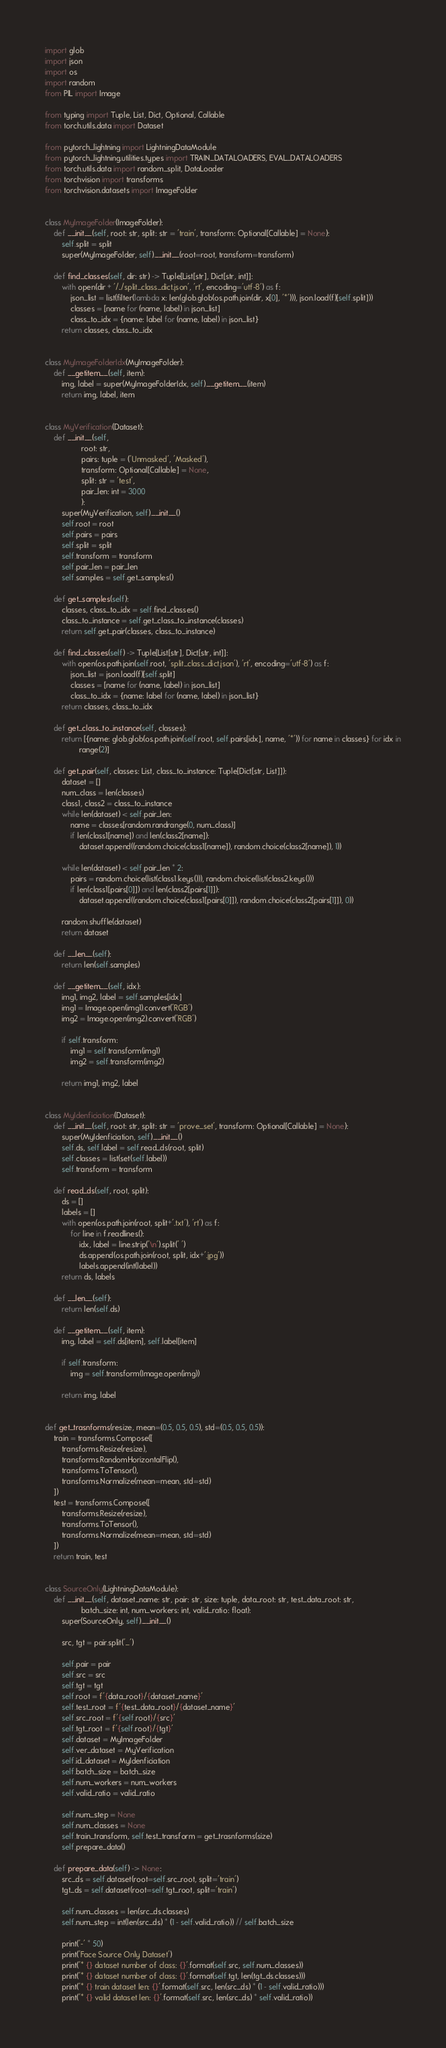Convert code to text. <code><loc_0><loc_0><loc_500><loc_500><_Python_>import glob
import json
import os
import random
from PIL import Image

from typing import Tuple, List, Dict, Optional, Callable
from torch.utils.data import Dataset

from pytorch_lightning import LightningDataModule
from pytorch_lightning.utilities.types import TRAIN_DATALOADERS, EVAL_DATALOADERS
from torch.utils.data import random_split, DataLoader
from torchvision import transforms
from torchvision.datasets import ImageFolder


class MyImageFolder(ImageFolder):
    def __init__(self, root: str, split: str = 'train', transform: Optional[Callable] = None):
        self.split = split
        super(MyImageFolder, self).__init__(root=root, transform=transform)

    def find_classes(self, dir: str) -> Tuple[List[str], Dict[str, int]]:
        with open(dir + '/../split_class_dict.json', 'rt', encoding='utf-8') as f:
            json_list = list(filter(lambda x: len(glob.glob(os.path.join(dir, x[0], '*'))), json.load(f)[self.split]))
            classes = [name for (name, label) in json_list]
            class_to_idx = {name: label for (name, label) in json_list}
        return classes, class_to_idx


class MyImageFolderIdx(MyImageFolder):
    def __getitem__(self, item):
        img, label = super(MyImageFolderIdx, self).__getitem__(item)
        return img, label, item


class MyVerification(Dataset):
    def __init__(self,
                 root: str,
                 pairs: tuple = ('Unmasked', 'Masked'),
                 transform: Optional[Callable] = None,
                 split: str = 'test',
                 pair_len: int = 3000
                 ):
        super(MyVerification, self).__init__()
        self.root = root
        self.pairs = pairs
        self.split = split
        self.transform = transform
        self.pair_len = pair_len
        self.samples = self.get_samples()

    def get_samples(self):
        classes, class_to_idx = self.find_classes()
        class_to_instance = self.get_class_to_instance(classes)
        return self.get_pair(classes, class_to_instance)

    def find_classes(self) -> Tuple[List[str], Dict[str, int]]:
        with open(os.path.join(self.root, 'split_class_dict.json'), 'rt', encoding='utf-8') as f:
            json_list = json.load(f)[self.split]
            classes = [name for (name, label) in json_list]
            class_to_idx = {name: label for (name, label) in json_list}
        return classes, class_to_idx

    def get_class_to_instance(self, classes):
        return [{name: glob.glob(os.path.join(self.root, self.pairs[idx], name, '*')) for name in classes} for idx in
                range(2)]

    def get_pair(self, classes: List, class_to_instance: Tuple[Dict[str, List]]):
        dataset = []
        num_class = len(classes)
        class1, class2 = class_to_instance
        while len(dataset) < self.pair_len:
            name = classes[random.randrange(0, num_class)]
            if len(class1[name]) and len(class2[name]):
                dataset.append((random.choice(class1[name]), random.choice(class2[name]), 1))

        while len(dataset) < self.pair_len * 2:
            pairs = random.choice(list(class1.keys())), random.choice(list(class2.keys()))
            if len(class1[pairs[0]]) and len(class2[pairs[1]]):
                dataset.append((random.choice(class1[pairs[0]]), random.choice(class2[pairs[1]]), 0))

        random.shuffle(dataset)
        return dataset

    def __len__(self):
        return len(self.samples)

    def __getitem__(self, idx):
        img1, img2, label = self.samples[idx]
        img1 = Image.open(img1).convert('RGB')
        img2 = Image.open(img2).convert('RGB')

        if self.transform:
            img1 = self.transform(img1)
            img2 = self.transform(img2)

        return img1, img2, label


class MyIdenficiation(Dataset):
    def __init__(self, root: str, split: str = 'prove_set', transform: Optional[Callable] = None):
        super(MyIdenficiation, self).__init__()
        self.ds, self.label = self.read_ds(root, split)
        self.classes = list(set(self.label))
        self.transform = transform

    def read_ds(self, root, split):
        ds = []
        labels = []
        with open(os.path.join(root, split+'.txt'), 'rt') as f:
            for line in f.readlines():
                idx, label = line.strip('\n').split(' ')
                ds.append(os.path.join(root, split, idx+'.jpg'))
                labels.append(int(label))
        return ds, labels

    def __len__(self):
        return len(self.ds)

    def __getitem__(self, item):
        img, label = self.ds[item], self.label[item]

        if self.transform:
            img = self.transform(Image.open(img))

        return img, label


def get_trasnforms(resize, mean=(0.5, 0.5, 0.5), std=(0.5, 0.5, 0.5)):
    train = transforms.Compose([
        transforms.Resize(resize),
        transforms.RandomHorizontalFlip(),
        transforms.ToTensor(),
        transforms.Normalize(mean=mean, std=std)
    ])
    test = transforms.Compose([
        transforms.Resize(resize),
        transforms.ToTensor(),
        transforms.Normalize(mean=mean, std=std)
    ])
    return train, test


class SourceOnly(LightningDataModule):
    def __init__(self, dataset_name: str, pair: str, size: tuple, data_root: str, test_data_root: str,
                 batch_size: int, num_workers: int, valid_ratio: float):
        super(SourceOnly, self).__init__()

        src, tgt = pair.split('_')

        self.pair = pair
        self.src = src
        self.tgt = tgt
        self.root = f'{data_root}/{dataset_name}'
        self.test_root = f'{test_data_root}/{dataset_name}'
        self.src_root = f'{self.root}/{src}'
        self.tgt_root = f'{self.root}/{tgt}'
        self.dataset = MyImageFolder
        self.ver_dataset = MyVerification
        self.id_dataset = MyIdenficiation
        self.batch_size = batch_size
        self.num_workers = num_workers
        self.valid_ratio = valid_ratio

        self.num_step = None
        self.num_classes = None
        self.train_transform, self.test_transform = get_trasnforms(size)
        self.prepare_data()

    def prepare_data(self) -> None:
        src_ds = self.dataset(root=self.src_root, split='train')
        tgt_ds = self.dataset(root=self.tgt_root, split='train')

        self.num_classes = len(src_ds.classes)
        self.num_step = int(len(src_ds) * (1 - self.valid_ratio)) // self.batch_size

        print('-' * 50)
        print('Face Source Only Dataset')
        print('* {} dataset number of class: {}'.format(self.src, self.num_classes))
        print('* {} dataset number of class: {}'.format(self.tgt, len(tgt_ds.classes)))
        print('* {} train dataset len: {}'.format(self.src, len(src_ds) * (1 - self.valid_ratio)))
        print('* {} valid dataset len: {}'.format(self.src, len(src_ds) * self.valid_ratio))</code> 